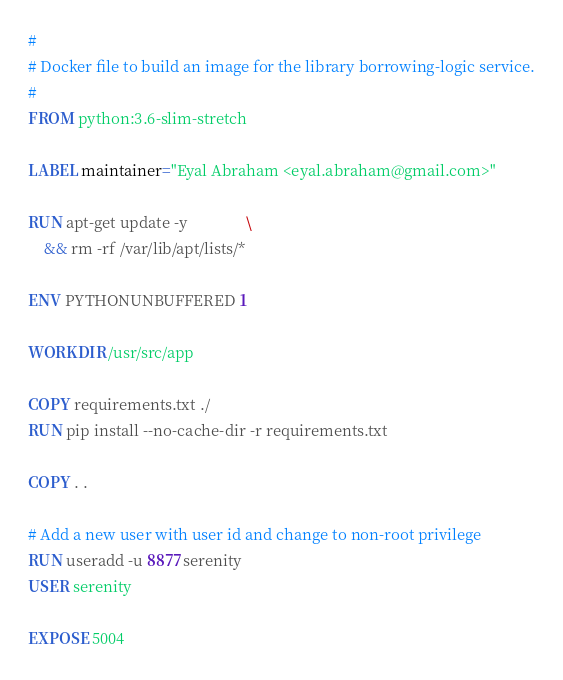Convert code to text. <code><loc_0><loc_0><loc_500><loc_500><_Dockerfile_>#
# Docker file to build an image for the library borrowing-logic service.
#
FROM python:3.6-slim-stretch

LABEL maintainer="Eyal Abraham <eyal.abraham@gmail.com>"

RUN apt-get update -y               \
    && rm -rf /var/lib/apt/lists/*
    
ENV PYTHONUNBUFFERED 1

WORKDIR /usr/src/app

COPY requirements.txt ./
RUN pip install --no-cache-dir -r requirements.txt

COPY . .

# Add a new user with user id and change to non-root privilege
RUN useradd -u 8877 serenity
USER serenity

EXPOSE 5004
</code> 